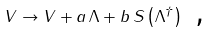<formula> <loc_0><loc_0><loc_500><loc_500>V \rightarrow V + a \, \Lambda + b \, S \left ( \Lambda ^ { \dagger } \right ) \text { ,}</formula> 